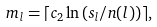<formula> <loc_0><loc_0><loc_500><loc_500>m _ { l } = \lceil c _ { 2 } \ln \left ( s _ { l } / n ( l ) \right ) \rceil ,</formula> 